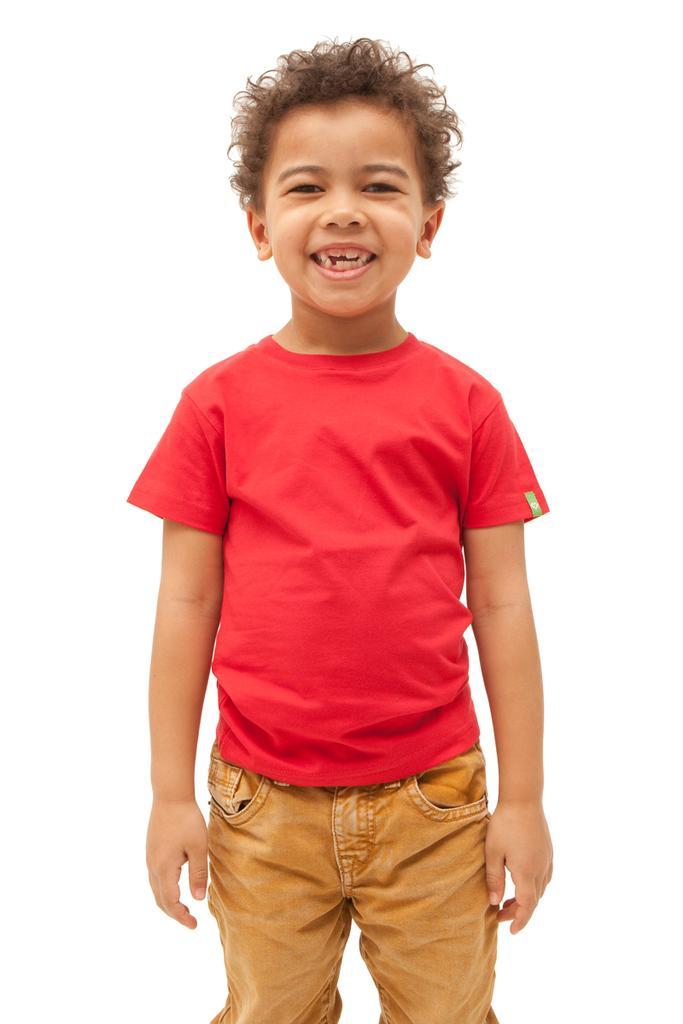Can you describe this image briefly? In this image we can see a boy standing and wearing a red color shirt and cream color pant. 